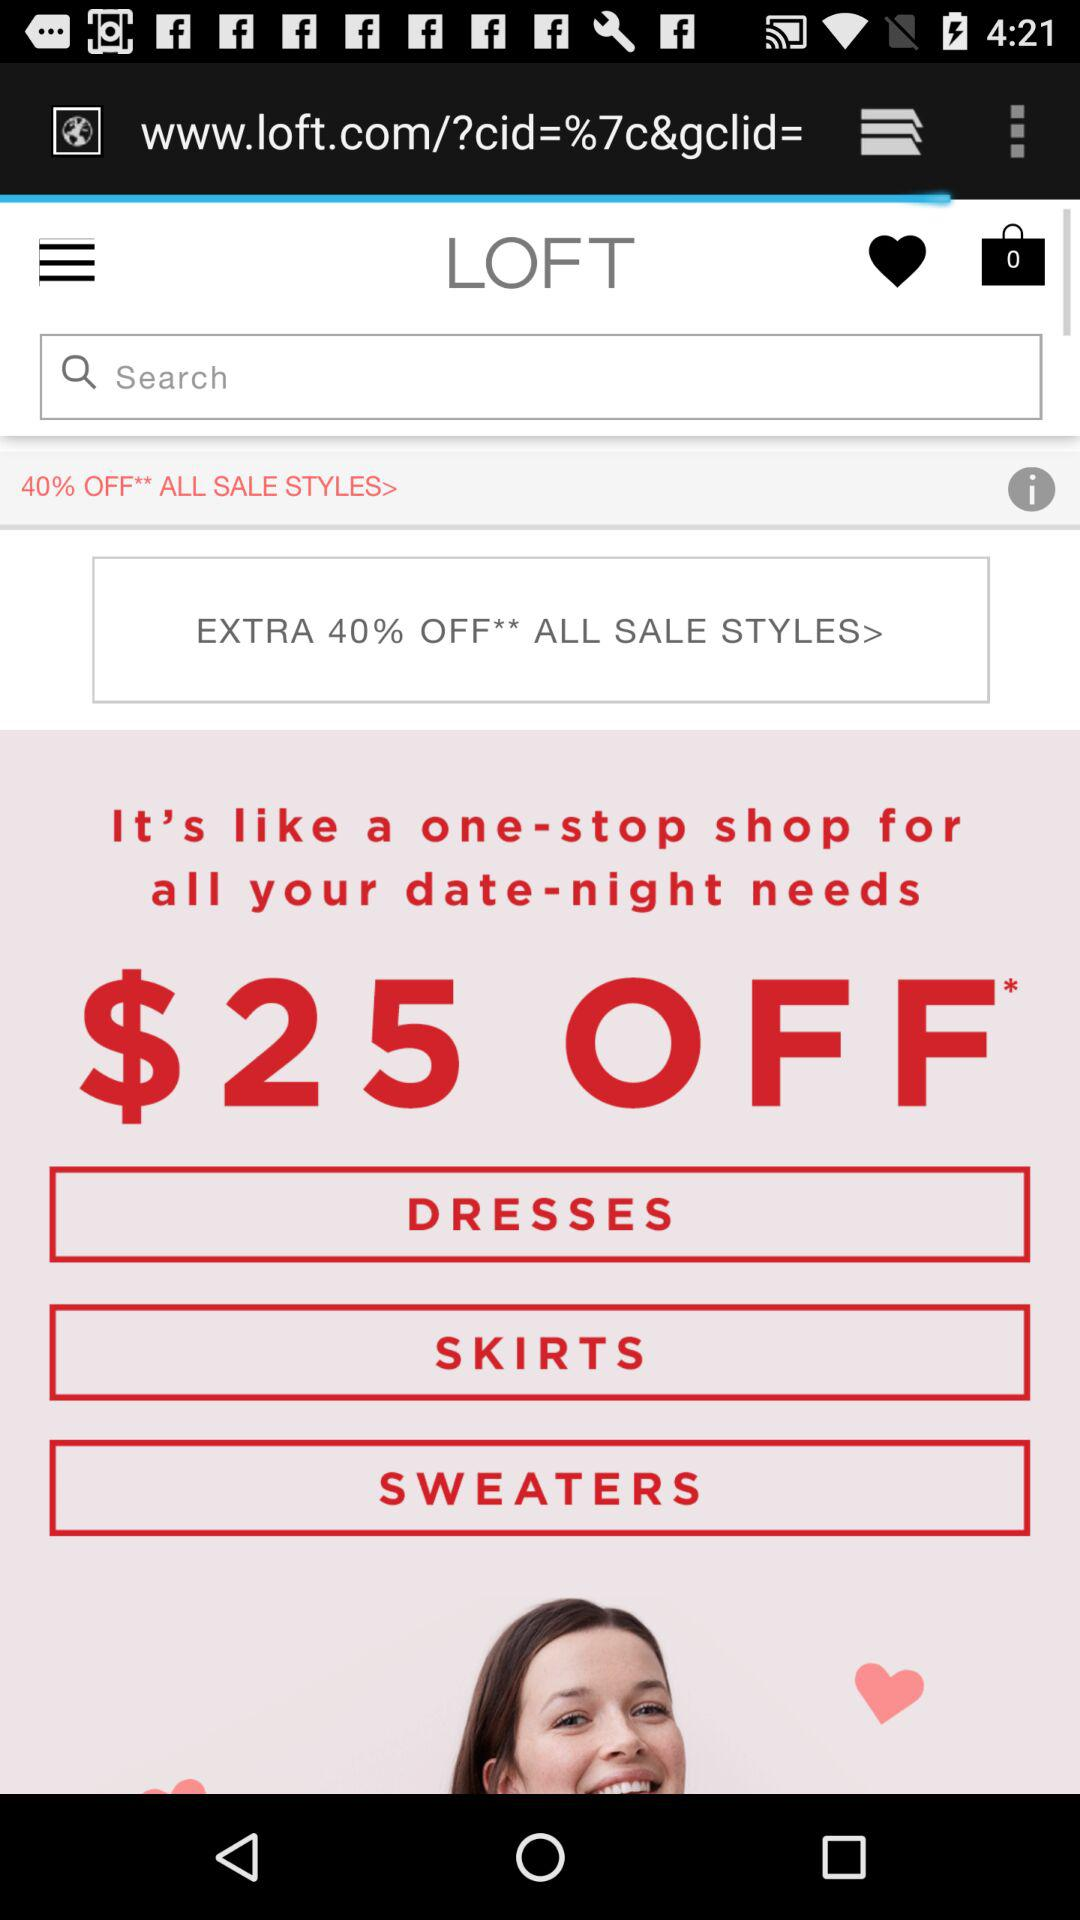How many items are in the bag? There are 0 items. 